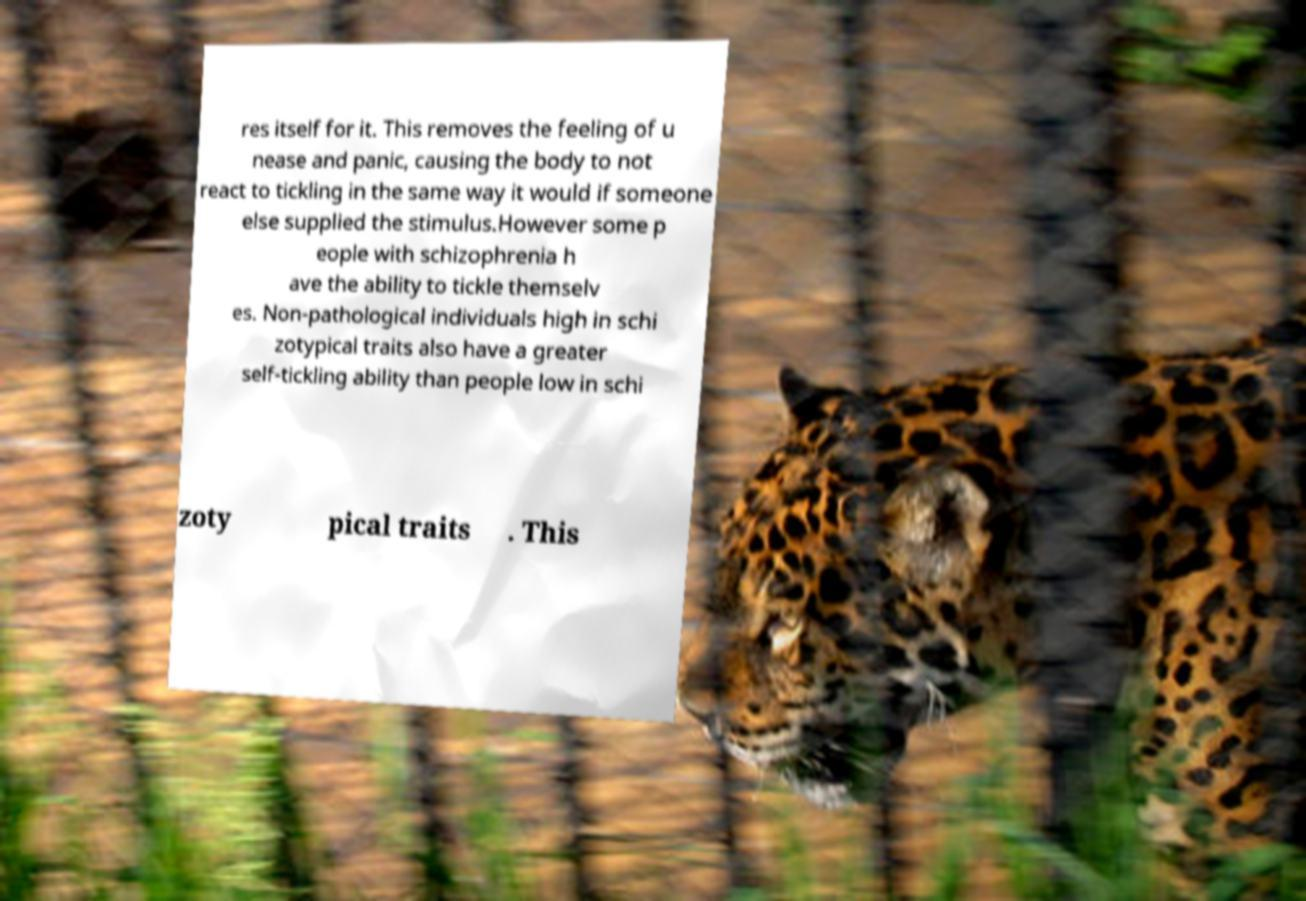Please read and relay the text visible in this image. What does it say? res itself for it. This removes the feeling of u nease and panic, causing the body to not react to tickling in the same way it would if someone else supplied the stimulus.However some p eople with schizophrenia h ave the ability to tickle themselv es. Non-pathological individuals high in schi zotypical traits also have a greater self-tickling ability than people low in schi zoty pical traits . This 